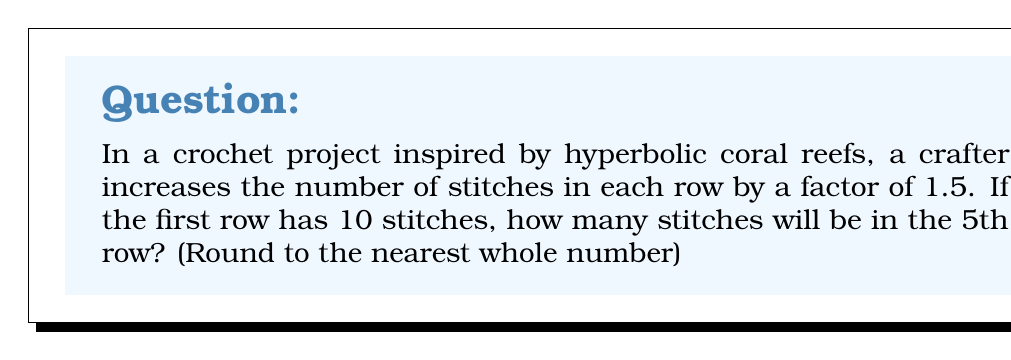Can you answer this question? Let's approach this step-by-step:

1) We start with 10 stitches in the first row.

2) Each subsequent row increases by a factor of 1.5. This means we multiply the number of stitches in each row by 1.5 to get the number in the next row.

3) Let's calculate the number of stitches for each row:

   Row 1: 10 stitches
   Row 2: $10 * 1.5 = 15$ stitches
   Row 3: $15 * 1.5 = 22.5$ stitches (round to 23)
   Row 4: $22.5 * 1.5 = 33.75$ stitches (round to 34)
   Row 5: $33.75 * 1.5 = 50.625$ stitches

4) Rounding 50.625 to the nearest whole number gives us 51.

This exponential growth in the number of stitches is what creates the hyperbolic curvature in the crochet pattern, mimicking the structure of coral reefs. The increasing density of stitches causes the fabric to ruffle and fold, creating intricate, organic-looking shapes.
Answer: 51 stitches 